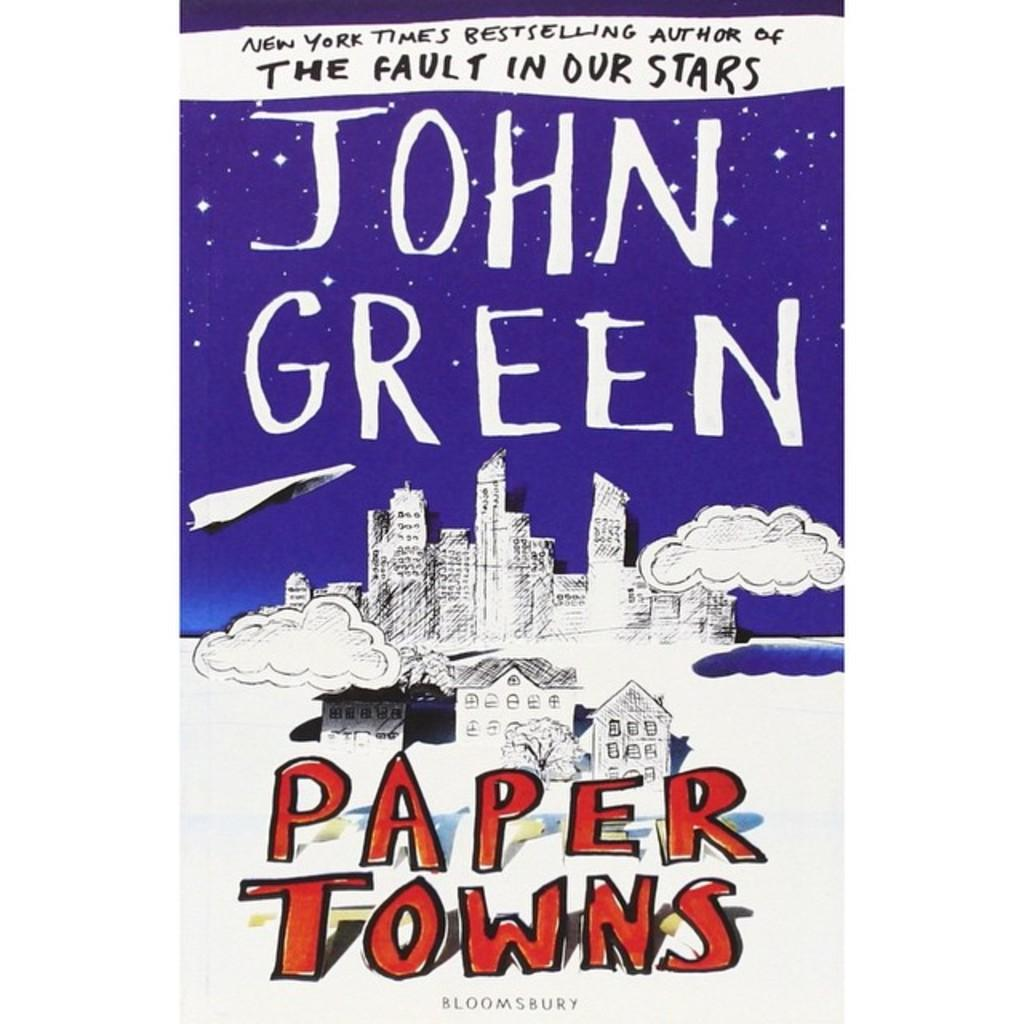<image>
Render a clear and concise summary of the photo. The blue and white cover of the book "Paper Towns" by John Green. 